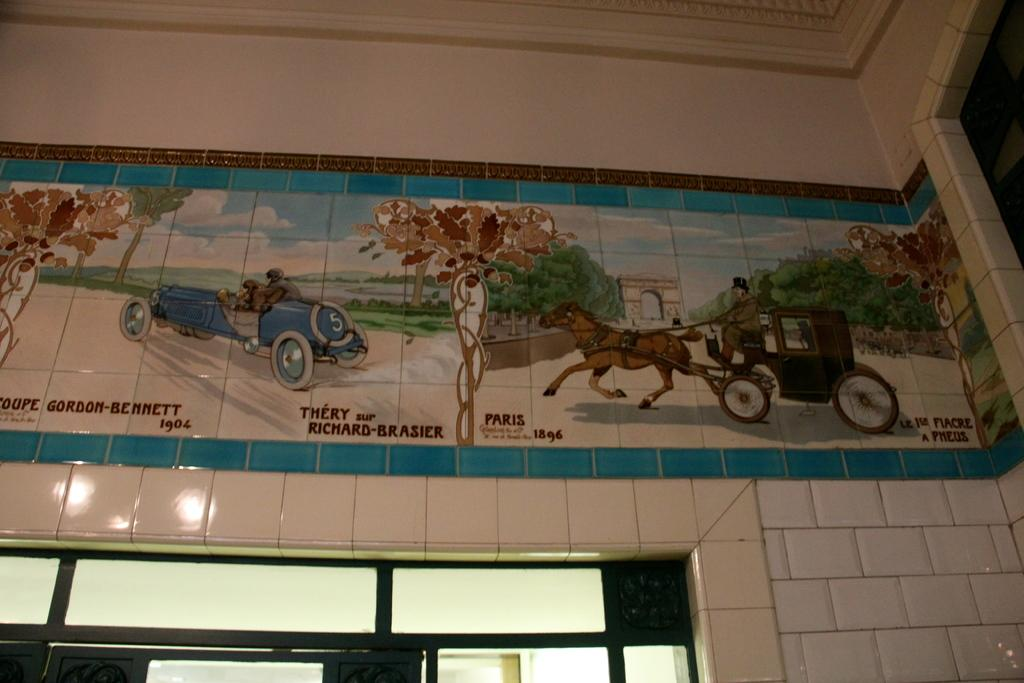What is present on the wall in the image? There is a painting on the wall. What elements can be seen in the painting? The painting contains trees, an arch, a vehicle, and a cart. Can you describe the setting of the painting? The painting depicts a scene with trees, an arch, and a vehicle and cart, suggesting a park or outdoor area. Where is the bucket located in the image? There is no bucket present in the image. What is the height of the finger in the image? There are no fingers present in the image. 